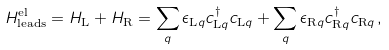Convert formula to latex. <formula><loc_0><loc_0><loc_500><loc_500>H ^ { \text {el} } _ { \text {leads} } = H _ { \text {L} } + H _ { \text {R} } = \sum _ { q } \epsilon _ { \text {L} q } c ^ { \dagger } _ { \text {L} q } c _ { \text {L} q } + \sum _ { q } \epsilon _ { \text {R} q } c ^ { \dagger } _ { \text {R} q } c _ { \text {R} q } \, ,</formula> 